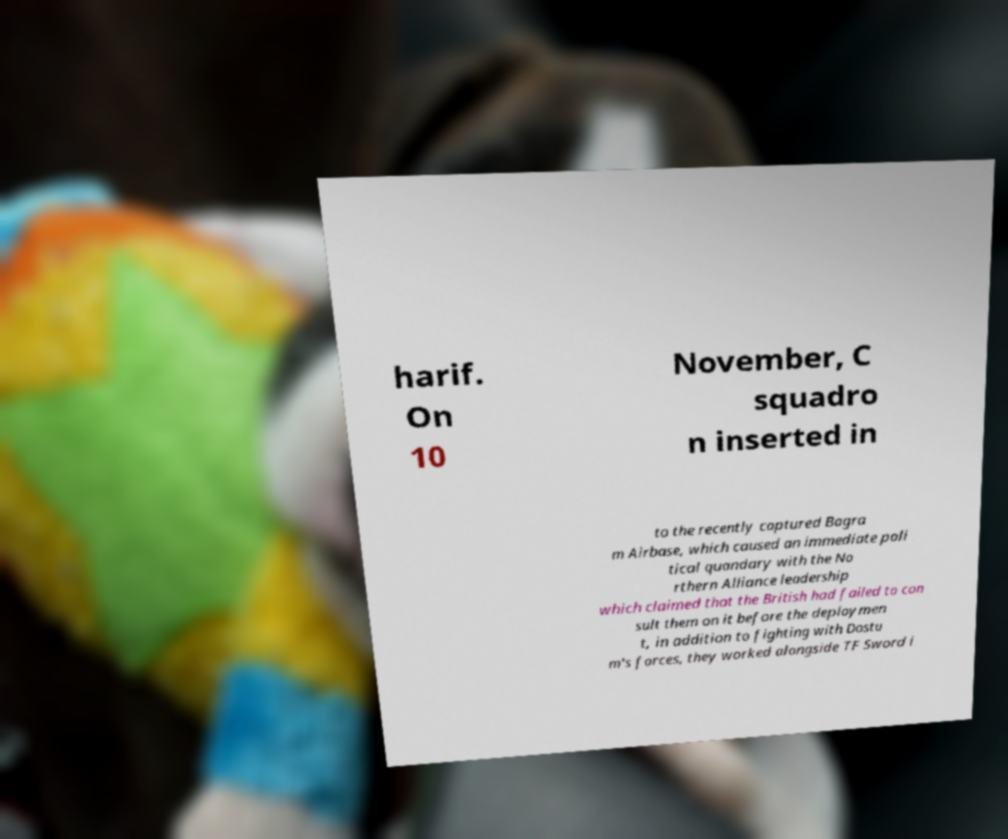There's text embedded in this image that I need extracted. Can you transcribe it verbatim? harif. On 10 November, C squadro n inserted in to the recently captured Bagra m Airbase, which caused an immediate poli tical quandary with the No rthern Alliance leadership which claimed that the British had failed to con sult them on it before the deploymen t, in addition to fighting with Dostu m's forces, they worked alongside TF Sword i 